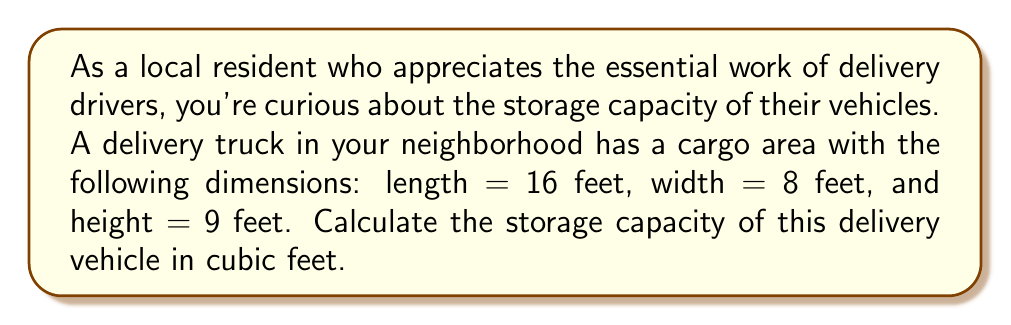Help me with this question. To calculate the storage capacity of the delivery vehicle, we need to find the volume of the cargo area. The volume of a rectangular prism (which is the shape of most cargo areas) is given by the formula:

$$V = l \times w \times h$$

Where:
$V$ = volume
$l$ = length
$w$ = width
$h$ = height

Given dimensions:
$l = 16$ feet
$w = 8$ feet
$h = 9$ feet

Let's substitute these values into the formula:

$$V = 16 \times 8 \times 9$$

Now, let's perform the multiplication:

$$V = 128 \times 9 = 1,152$$

Therefore, the storage capacity of the delivery vehicle is 1,152 cubic feet.
Answer: $1,152$ cubic feet 